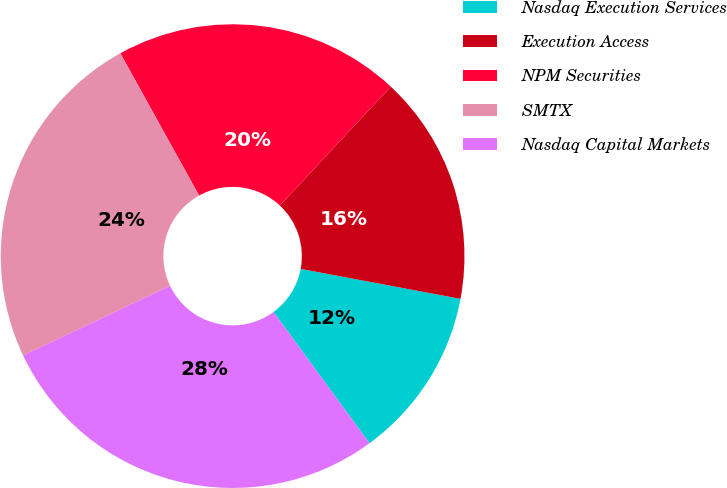<chart> <loc_0><loc_0><loc_500><loc_500><pie_chart><fcel>Nasdaq Execution Services<fcel>Execution Access<fcel>NPM Securities<fcel>SMTX<fcel>Nasdaq Capital Markets<nl><fcel>12.0%<fcel>16.0%<fcel>20.0%<fcel>24.0%<fcel>28.0%<nl></chart> 